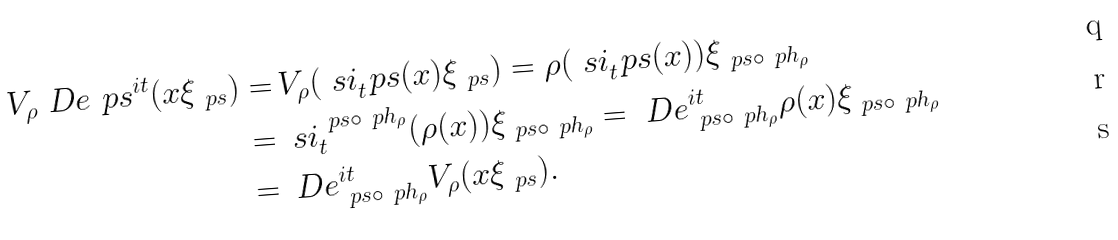<formula> <loc_0><loc_0><loc_500><loc_500>V _ { \rho } \ D e _ { \ } p s ^ { i t } ( x \xi _ { \ p s } ) = & \, V _ { \rho } ( \ s i _ { t } ^ { \ } p s ( x ) \xi _ { \ p s } ) = \rho ( \ s i _ { t } ^ { \ } p s ( x ) ) \xi _ { \ p s \circ \ p h _ { \rho } } \\ = & \, \ s i _ { t } ^ { \ p s \circ \ p h _ { \rho } } ( \rho ( x ) ) \xi _ { \ p s \circ \ p h _ { \rho } } = \ D e _ { \ p s \circ \ p h _ { \rho } } ^ { i t } \rho ( x ) \xi _ { \ p s \circ \ p h _ { \rho } } \\ = & \, \ D e _ { \ p s \circ \ p h _ { \rho } } ^ { i t } V _ { \rho } ( x \xi _ { \ p s } ) .</formula> 